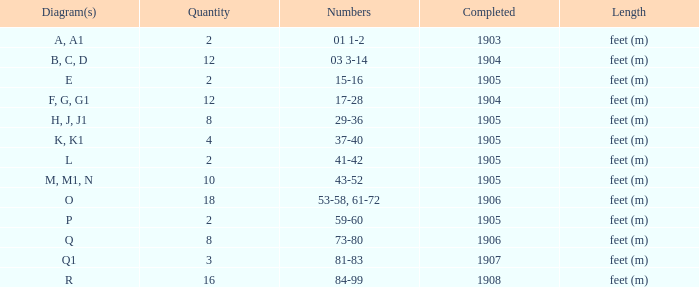For the element with greater than 10, and digits of 53-58, 61-72, what is the least accomplished? 1906.0. 